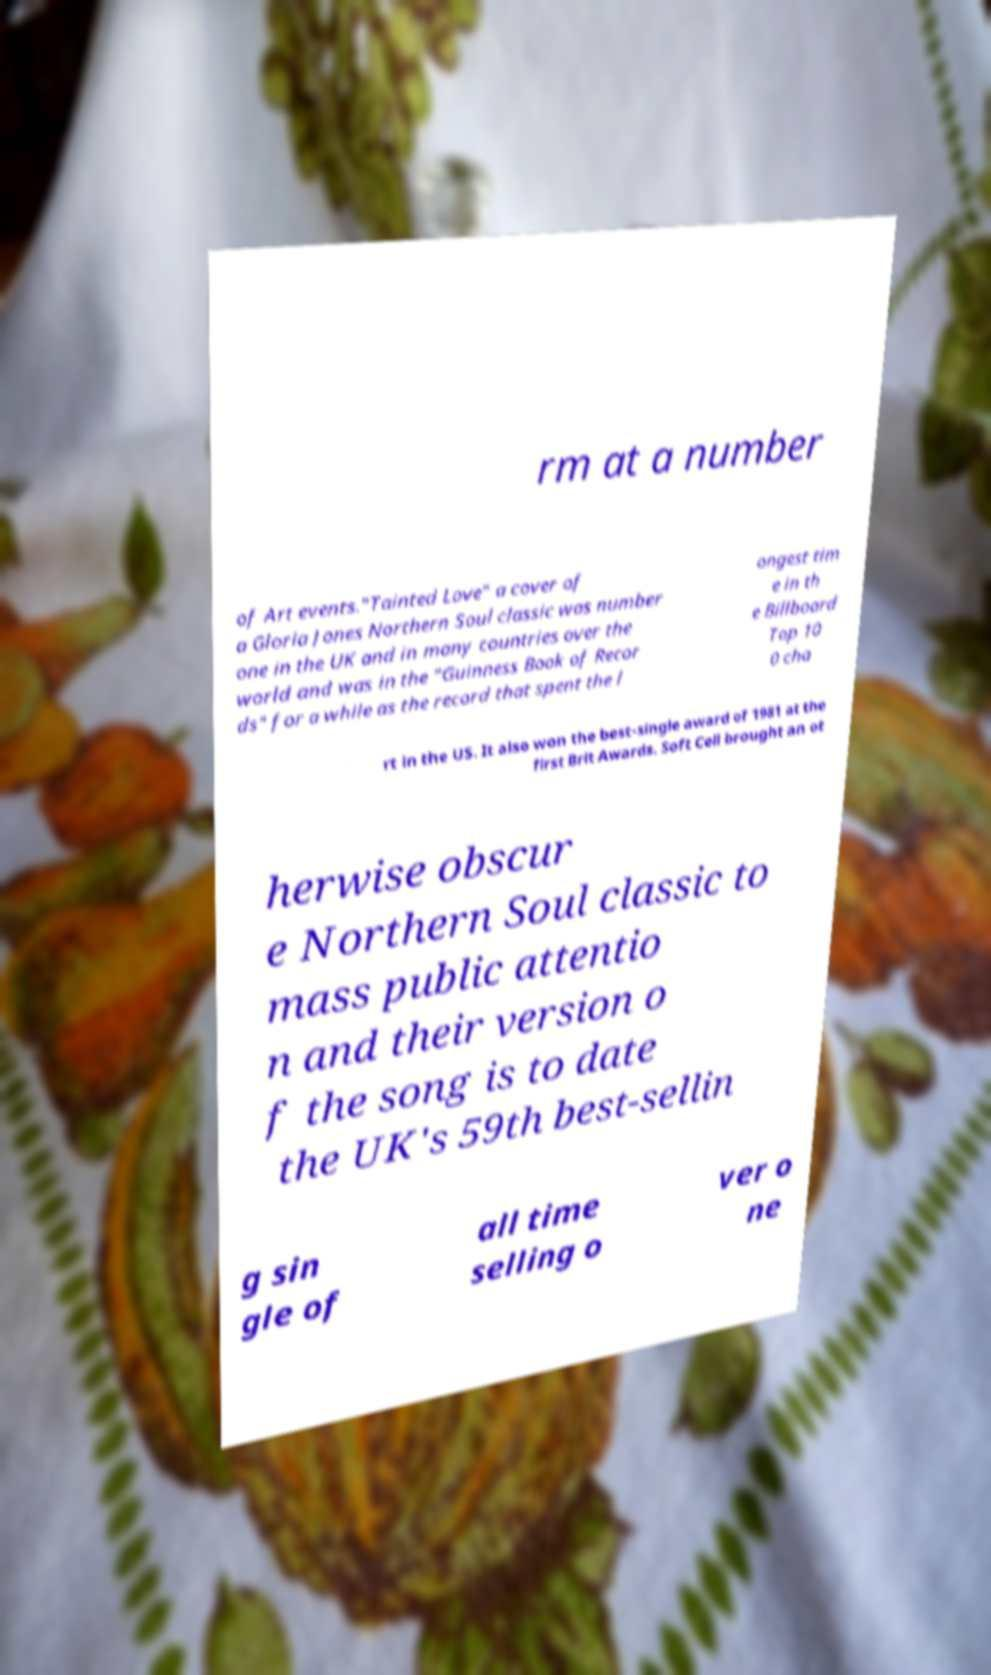I need the written content from this picture converted into text. Can you do that? rm at a number of Art events."Tainted Love" a cover of a Gloria Jones Northern Soul classic was number one in the UK and in many countries over the world and was in the "Guinness Book of Recor ds" for a while as the record that spent the l ongest tim e in th e Billboard Top 10 0 cha rt in the US. It also won the best-single award of 1981 at the first Brit Awards. Soft Cell brought an ot herwise obscur e Northern Soul classic to mass public attentio n and their version o f the song is to date the UK's 59th best-sellin g sin gle of all time selling o ver o ne 